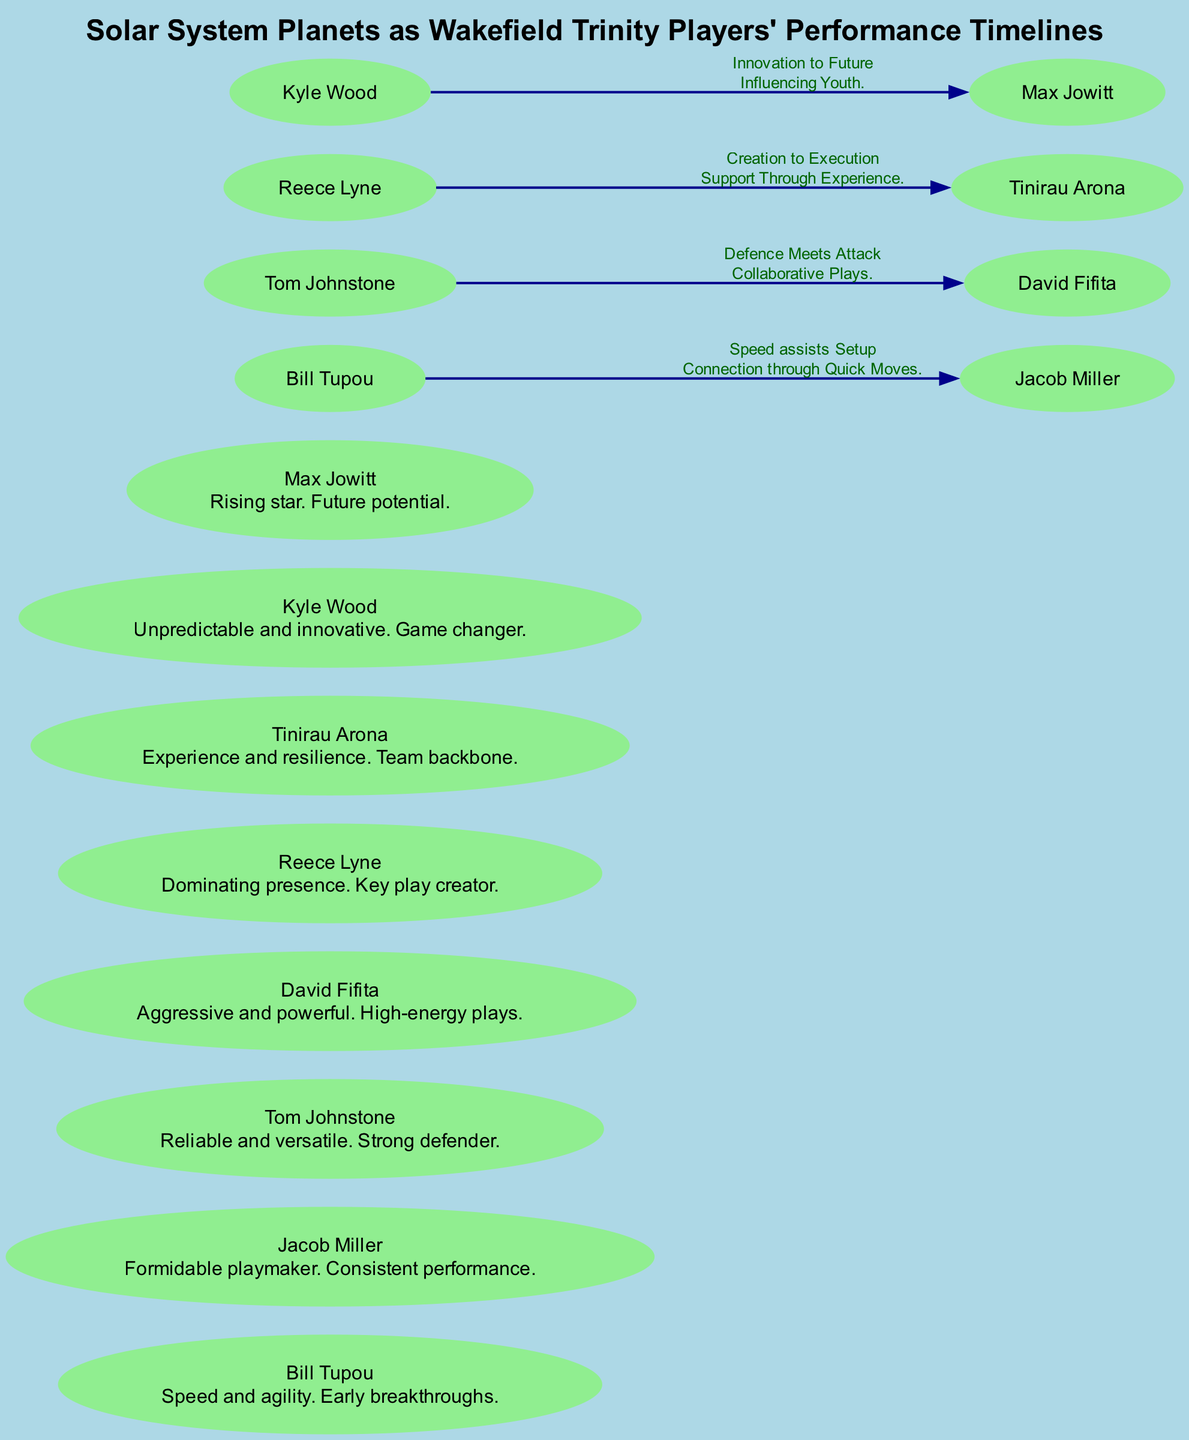What does the node Neptune represent? The node labeled Neptune in the diagram represents the player Max Jowitt, who is described as a rising star with future potential. This information is directly indicated in the node details.
Answer: Max Jowitt How many players are represented as planets in the diagram? There are a total of eight players represented as nodes in the diagram, each corresponding to a planet in the solar system. This is determined by counting the nodes in the data.
Answer: Eight Which player is associated with aggressive and powerful plays? The player associated with aggressive and powerful plays is David Fifita, represented by the planet Mars. This can be found in the description of the Mars node.
Answer: David Fifita How does Kyle Wood influence Max Jowitt according to the diagram? Kyle Wood influences Max Jowitt through innovation that leads to the future, as described in the connection between these two nodes. This involves understanding the edge description connecting these players.
Answer: Innovation to Future What connections exist between Tom Johnstone and David Fifita? The connection between Tom Johnstone and David Fifita is labeled "Defence Meets Attack," which describes their collaborative plays. This includes interpreting the edge that connects these two nodes.
Answer: Defence Meets Attack Which player is described as having experience and resilience? The player described as having experience and resilience is Tinirau Arona, who corresponds to the planet Saturn in the diagram. This is specifically mentioned in the node description for Saturn.
Answer: Tinirau Arona What role does Reece Lyne play in the team's strategy? Reece Lyne plays the role of a key play creator, as indicated in the description associated with the Jupiter node. This succinctly conveys his strategic importance in the team.
Answer: Key play creator How many connections (edges) are illustrated in the diagram? There are four connections illustrated in the diagram, which can be counted based on the edges provided in the data. Each edge connects different nodes, forming relationships between the players.
Answer: Four 